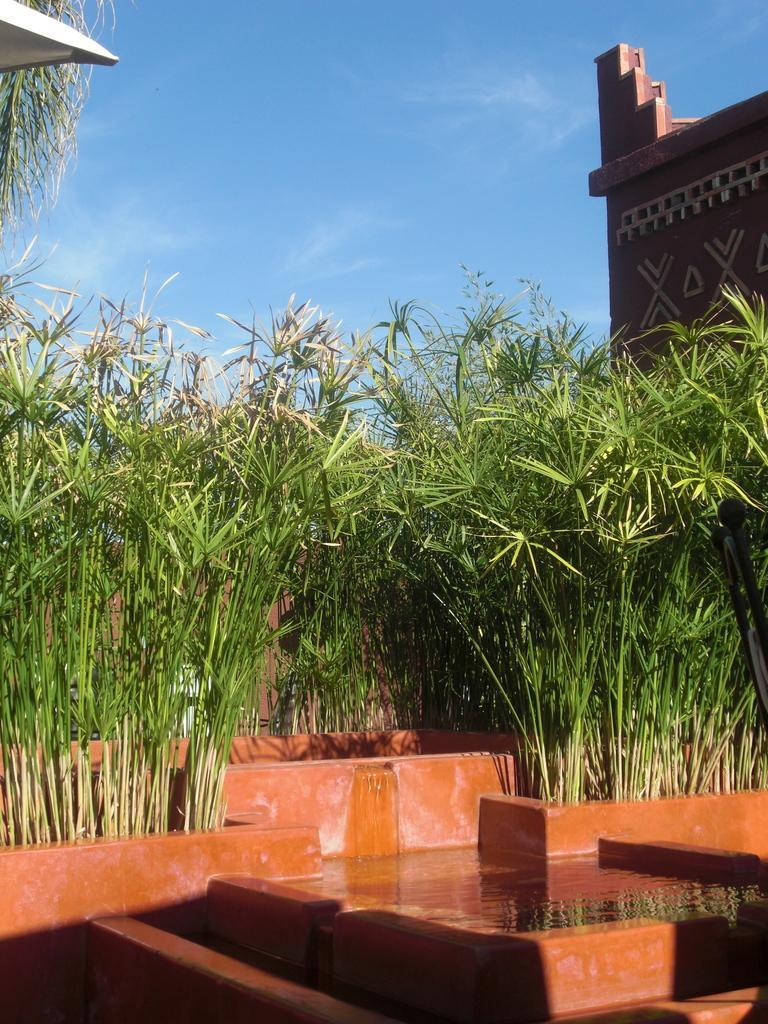Can you describe this image briefly? There is some water at the bottom of this image, and there are some plants as we can see in the middle of this image. There is a wall on the right side of this image and there is a blue sky at the top of this image. 